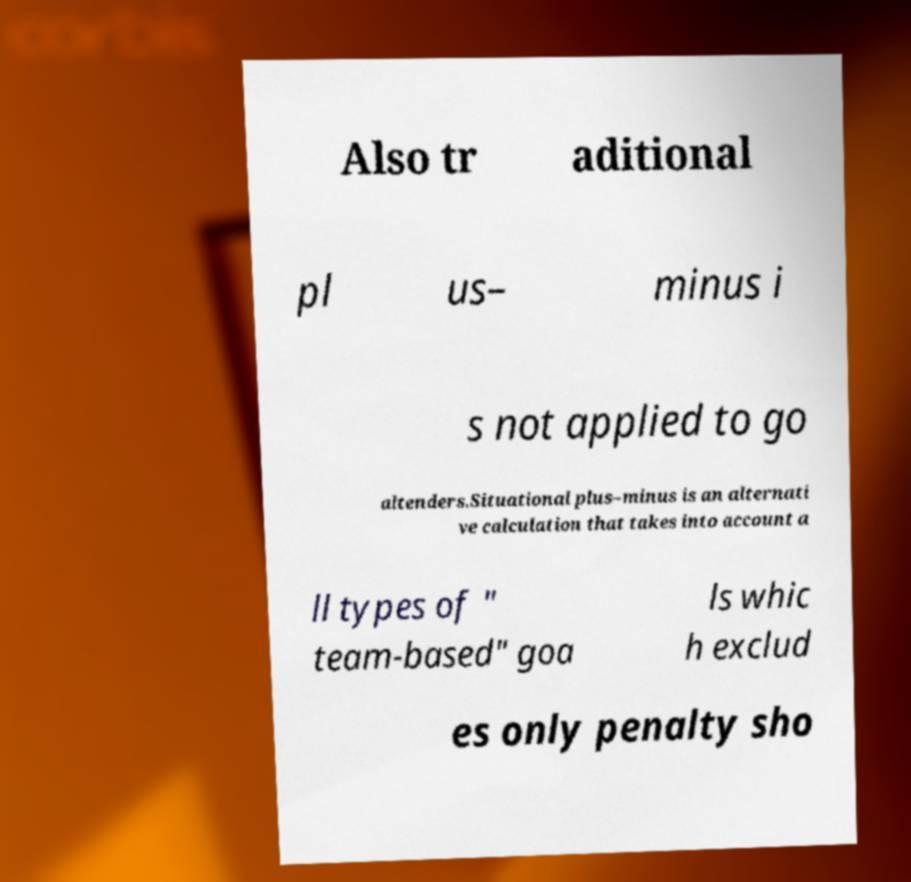Can you accurately transcribe the text from the provided image for me? Also tr aditional pl us– minus i s not applied to go altenders.Situational plus–minus is an alternati ve calculation that takes into account a ll types of " team-based" goa ls whic h exclud es only penalty sho 